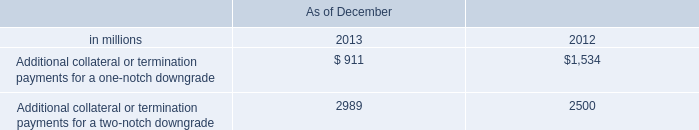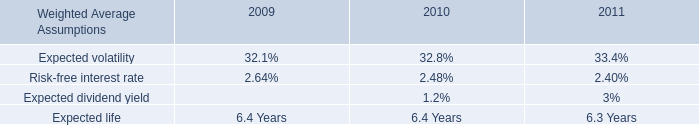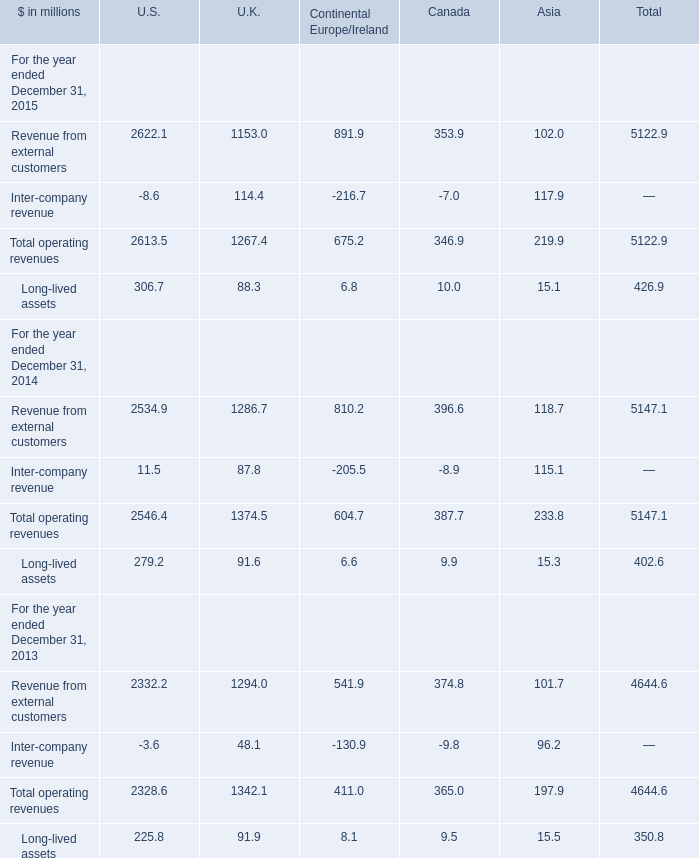for cash and cash equivalents at the end of 2013 , what percentage was generated from operating activities? 
Computations: (4.54 / 61.13)
Answer: 0.07427. Which year is Total operating revenues in terms of Canada the lowest? 
Answer: 2015. 